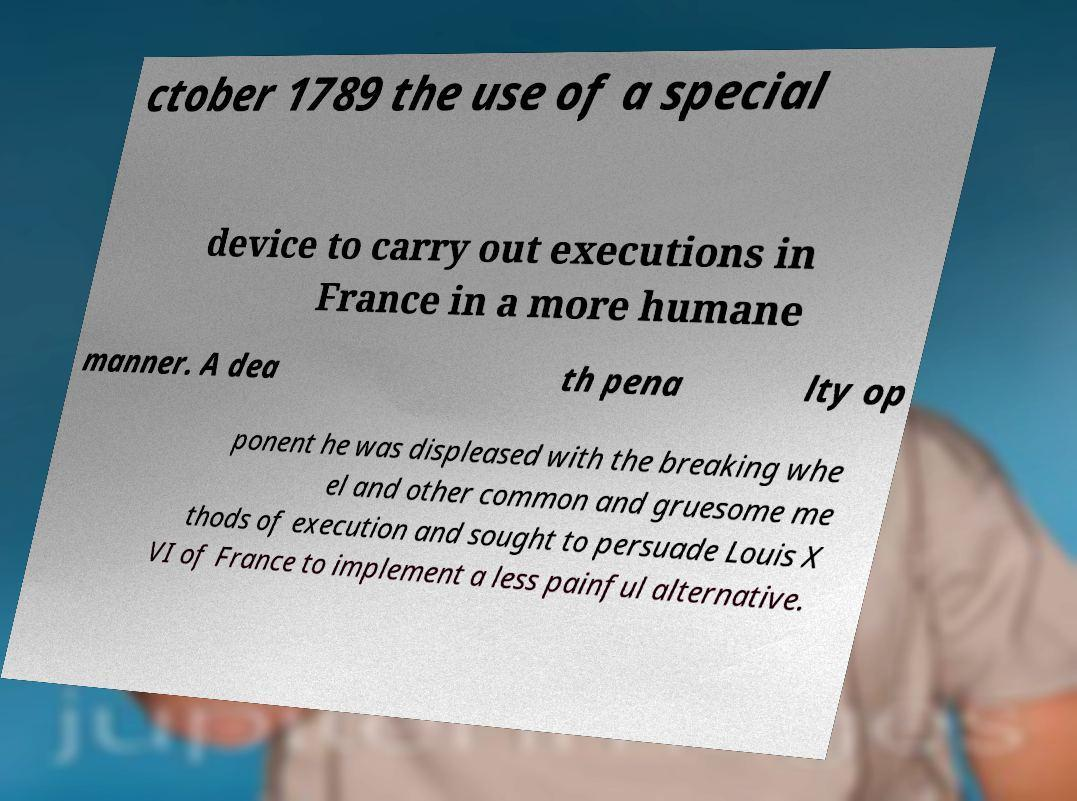Please identify and transcribe the text found in this image. ctober 1789 the use of a special device to carry out executions in France in a more humane manner. A dea th pena lty op ponent he was displeased with the breaking whe el and other common and gruesome me thods of execution and sought to persuade Louis X VI of France to implement a less painful alternative. 